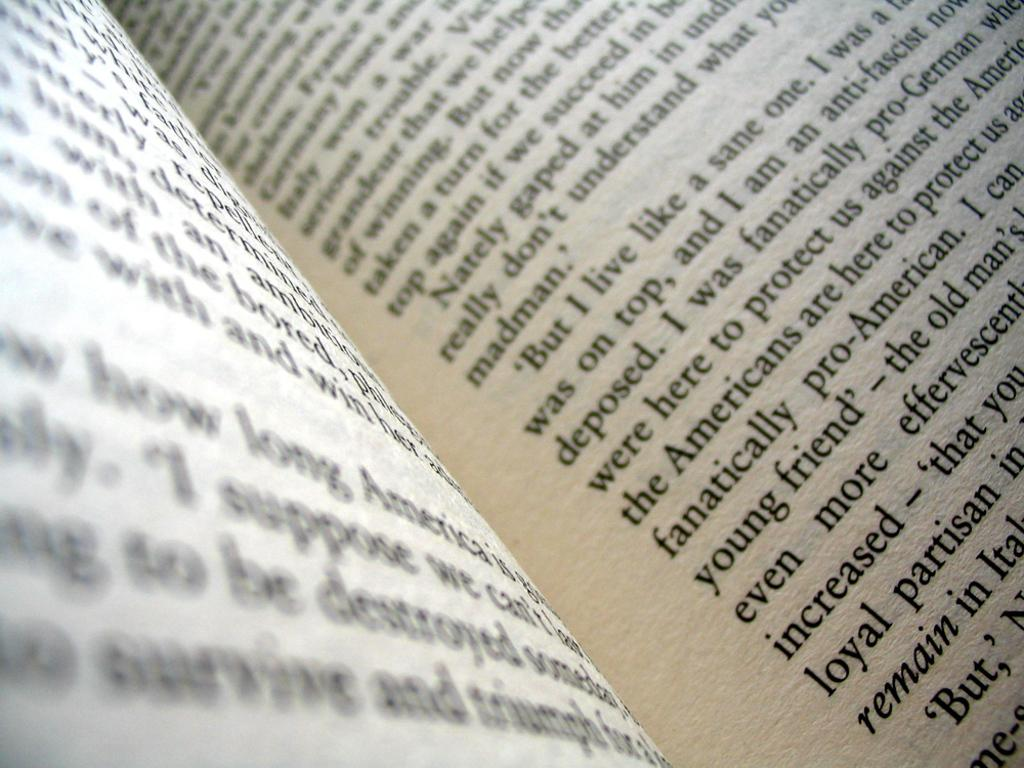<image>
Provide a brief description of the given image. An open book with the words 'But I live like a sane one' visible. 